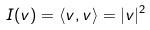Convert formula to latex. <formula><loc_0><loc_0><loc_500><loc_500>I ( v ) = \langle v , v \rangle = | v | ^ { 2 }</formula> 